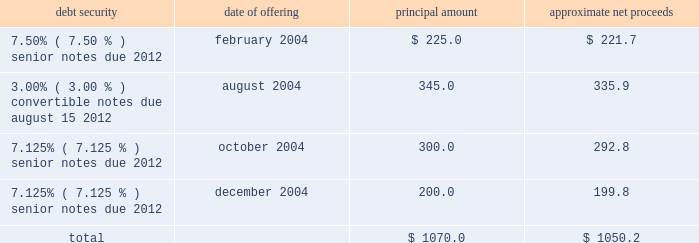Proceeds from the sale of equity securities .
From time to time , we raise funds through public offerings of our equity securities .
In addition , we receive proceeds from sales of our equity securities pursuant to our stock option and stock purchase plans .
For the year ended december 31 , 2004 , we received approximately $ 40.6 million in proceeds from sales of shares of our class a common stock and the common stock of atc mexico pursuant to our stock option and stock purchase plans .
Financing activities during the year ended december 31 , 2004 , we took several actions to increase our financial flexibility and reduce our interest costs .
New credit facility .
In may 2004 , we refinanced our previous credit facility with a new $ 1.1 billion senior secured credit facility .
At closing , we received $ 685.5 million of net proceeds from the borrowings under the new facility , after deducting related expenses and fees , approximately $ 670.0 million of which we used to repay principal and interest under the previous credit facility .
We used the remaining net proceeds of $ 15.5 million for general corporate purposes , including the repurchase of other outstanding debt securities .
The new credit facility consists of the following : 2022 $ 400.0 million in undrawn revolving loan commitments , against which approximately $ 19.3 million of undrawn letters of credit were outstanding at december 31 , 2004 , maturing on february 28 , 2011 ; 2022 a $ 300.0 million term loan a , which is fully drawn , maturing on february 28 , 2011 ; and 2022 a $ 398.0 million term loan b , which is fully drawn , maturing on august 31 , 2011 .
The new credit facility extends the previous credit facility maturity dates from 2007 to 2011 for a majority of the borrowings outstanding , subject to earlier maturity upon the occurrence of certain events described below , and allows us to use credit facility borrowings and internally generated funds to repurchase other indebtedness without additional lender approval .
The new credit facility is guaranteed by us and is secured by a pledge of substantially all of our assets .
The maturity date for term loan a and any outstanding revolving loans will be accelerated to august 15 , 2008 , and the maturity date for term loan b will be accelerated to october 31 , 2008 , if ( 1 ) on or prior to august 1 , 2008 , our 93 20448% ( 20448 % ) senior notes have not been ( a ) refinanced with parent company indebtedness having a maturity date of february 28 , 2012 or later or with loans under the new credit facility , or ( b ) repaid , prepaid , redeemed , repurchased or otherwise retired , and ( 2 ) our consolidated leverage ratio ( total parent company debt to annualized operating cash flow ) at june 30 , 2008 is greater than 4.50 to 1.00 .
If this were to occur , the payments due in 2008 for term loan a and term loan b would be $ 225.0 million and $ 386.0 million , respectively .
Note offerings .
During 2004 , we raised approximately $ 1.1 billion in net proceeds from the sale of debt securities through institutional private placements as follows ( in millions ) : debt security date of offering principal amount approximate net proceeds .
2022 7.50% ( 7.50 % ) senior notes offering .
In february 2004 , we sold $ 225.0 million principal amount of our 7.50% ( 7.50 % ) senior notes due 2012 through an institutional private placement .
The 7.50% ( 7.50 % ) senior notes mature on may 1 , 2012 , and interest is payable semiannually in arrears on may 1 and november 1 of each year. .
What was the percent of the fees and cost for the processing of the 7.50% ( 7.50 % ) senior notes due 2012 issued february 2004? 
Computations: ((225.0 - 221.7) / 221.7)
Answer: 0.01488. 